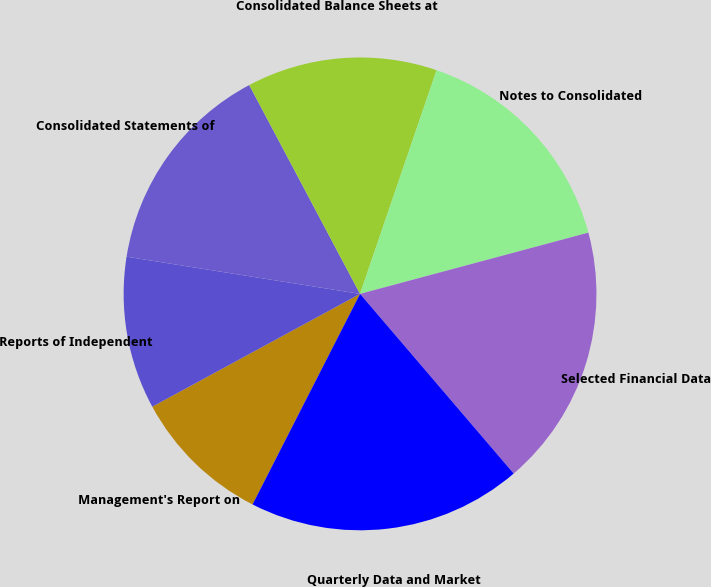Convert chart to OTSL. <chart><loc_0><loc_0><loc_500><loc_500><pie_chart><fcel>Management's Report on<fcel>Reports of Independent<fcel>Consolidated Statements of<fcel>Consolidated Balance Sheets at<fcel>Notes to Consolidated<fcel>Selected Financial Data<fcel>Quarterly Data and Market<nl><fcel>9.57%<fcel>10.43%<fcel>14.72%<fcel>13.01%<fcel>15.58%<fcel>17.91%<fcel>18.77%<nl></chart> 